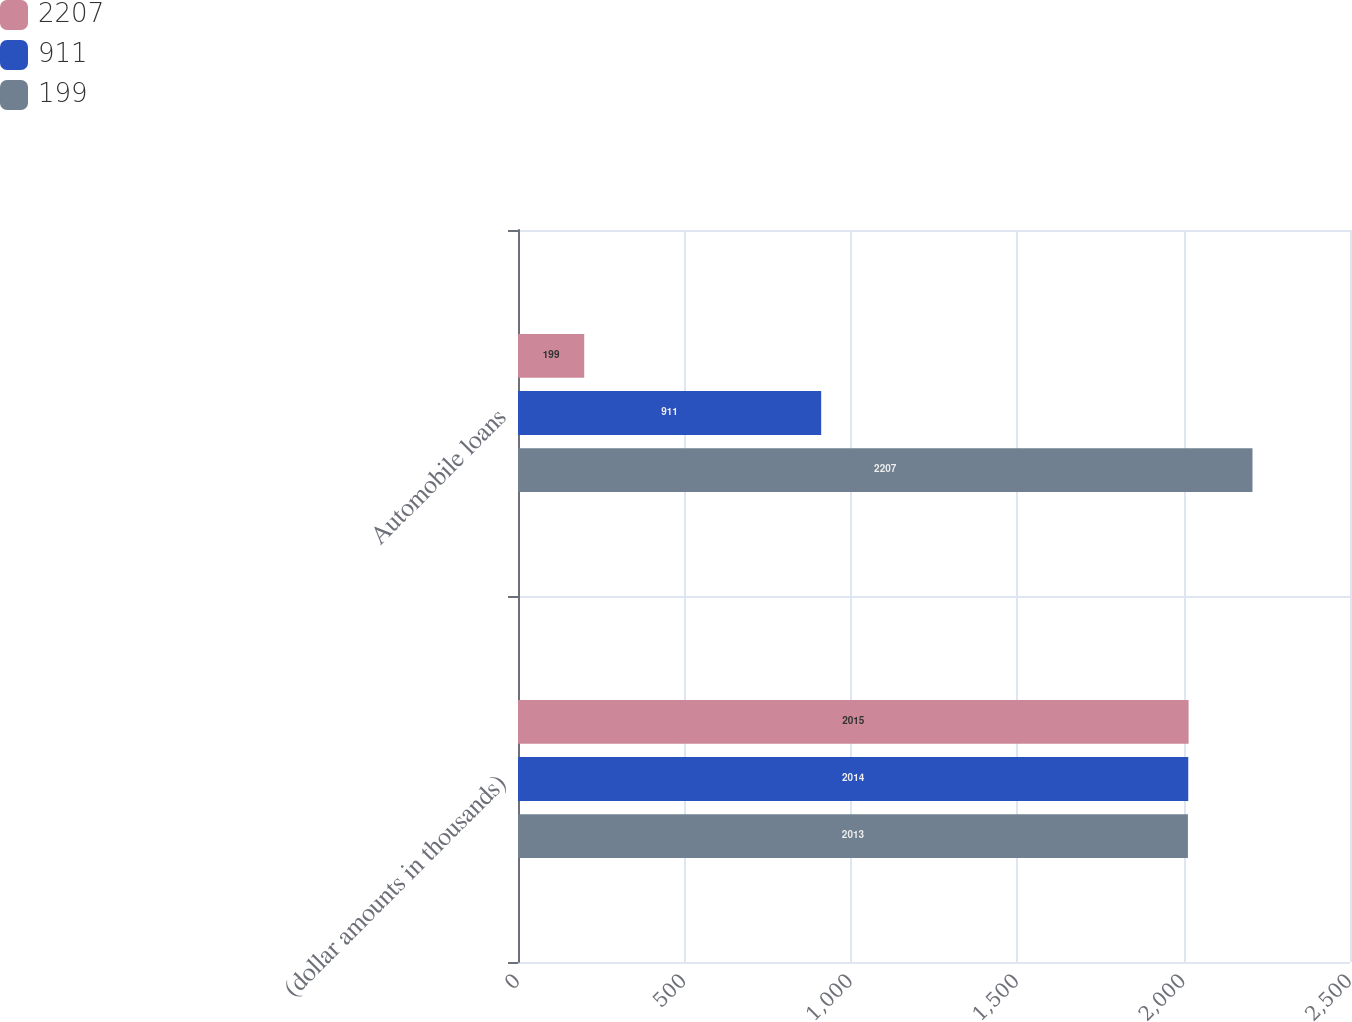Convert chart to OTSL. <chart><loc_0><loc_0><loc_500><loc_500><stacked_bar_chart><ecel><fcel>(dollar amounts in thousands)<fcel>Automobile loans<nl><fcel>2207<fcel>2015<fcel>199<nl><fcel>911<fcel>2014<fcel>911<nl><fcel>199<fcel>2013<fcel>2207<nl></chart> 